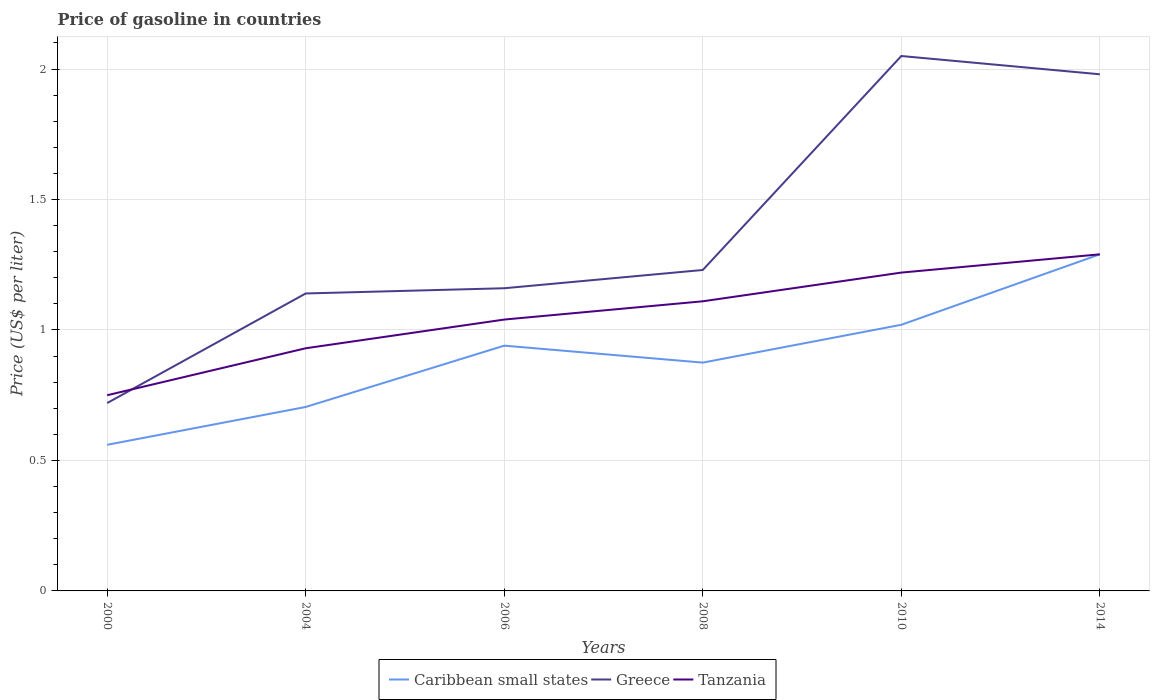How many different coloured lines are there?
Your answer should be very brief. 3. Does the line corresponding to Greece intersect with the line corresponding to Caribbean small states?
Your answer should be compact. No. Is the number of lines equal to the number of legend labels?
Your answer should be very brief. Yes. Across all years, what is the maximum price of gasoline in Greece?
Offer a very short reply. 0.72. In which year was the price of gasoline in Greece maximum?
Your answer should be compact. 2000. What is the total price of gasoline in Tanzania in the graph?
Provide a succinct answer. -0.36. What is the difference between the highest and the second highest price of gasoline in Caribbean small states?
Offer a terse response. 0.73. What is the difference between the highest and the lowest price of gasoline in Caribbean small states?
Keep it short and to the point. 3. Is the price of gasoline in Greece strictly greater than the price of gasoline in Caribbean small states over the years?
Provide a succinct answer. No. How many lines are there?
Provide a short and direct response. 3. What is the difference between two consecutive major ticks on the Y-axis?
Your answer should be compact. 0.5. Does the graph contain any zero values?
Give a very brief answer. No. Where does the legend appear in the graph?
Your answer should be compact. Bottom center. What is the title of the graph?
Make the answer very short. Price of gasoline in countries. Does "Haiti" appear as one of the legend labels in the graph?
Offer a very short reply. No. What is the label or title of the Y-axis?
Offer a very short reply. Price (US$ per liter). What is the Price (US$ per liter) in Caribbean small states in 2000?
Offer a very short reply. 0.56. What is the Price (US$ per liter) in Greece in 2000?
Make the answer very short. 0.72. What is the Price (US$ per liter) in Tanzania in 2000?
Provide a succinct answer. 0.75. What is the Price (US$ per liter) of Caribbean small states in 2004?
Ensure brevity in your answer.  0.7. What is the Price (US$ per liter) in Greece in 2004?
Offer a very short reply. 1.14. What is the Price (US$ per liter) in Tanzania in 2004?
Offer a very short reply. 0.93. What is the Price (US$ per liter) in Greece in 2006?
Offer a terse response. 1.16. What is the Price (US$ per liter) of Tanzania in 2006?
Offer a very short reply. 1.04. What is the Price (US$ per liter) in Greece in 2008?
Keep it short and to the point. 1.23. What is the Price (US$ per liter) of Tanzania in 2008?
Provide a succinct answer. 1.11. What is the Price (US$ per liter) in Greece in 2010?
Provide a short and direct response. 2.05. What is the Price (US$ per liter) in Tanzania in 2010?
Your response must be concise. 1.22. What is the Price (US$ per liter) of Caribbean small states in 2014?
Make the answer very short. 1.29. What is the Price (US$ per liter) of Greece in 2014?
Your answer should be compact. 1.98. What is the Price (US$ per liter) in Tanzania in 2014?
Ensure brevity in your answer.  1.29. Across all years, what is the maximum Price (US$ per liter) of Caribbean small states?
Your answer should be compact. 1.29. Across all years, what is the maximum Price (US$ per liter) of Greece?
Ensure brevity in your answer.  2.05. Across all years, what is the maximum Price (US$ per liter) in Tanzania?
Offer a terse response. 1.29. Across all years, what is the minimum Price (US$ per liter) in Caribbean small states?
Offer a terse response. 0.56. Across all years, what is the minimum Price (US$ per liter) in Greece?
Make the answer very short. 0.72. Across all years, what is the minimum Price (US$ per liter) in Tanzania?
Give a very brief answer. 0.75. What is the total Price (US$ per liter) in Caribbean small states in the graph?
Offer a terse response. 5.39. What is the total Price (US$ per liter) in Greece in the graph?
Your answer should be compact. 8.28. What is the total Price (US$ per liter) of Tanzania in the graph?
Provide a short and direct response. 6.34. What is the difference between the Price (US$ per liter) of Caribbean small states in 2000 and that in 2004?
Ensure brevity in your answer.  -0.14. What is the difference between the Price (US$ per liter) in Greece in 2000 and that in 2004?
Offer a very short reply. -0.42. What is the difference between the Price (US$ per liter) in Tanzania in 2000 and that in 2004?
Make the answer very short. -0.18. What is the difference between the Price (US$ per liter) in Caribbean small states in 2000 and that in 2006?
Offer a very short reply. -0.38. What is the difference between the Price (US$ per liter) in Greece in 2000 and that in 2006?
Provide a short and direct response. -0.44. What is the difference between the Price (US$ per liter) in Tanzania in 2000 and that in 2006?
Make the answer very short. -0.29. What is the difference between the Price (US$ per liter) of Caribbean small states in 2000 and that in 2008?
Give a very brief answer. -0.32. What is the difference between the Price (US$ per liter) of Greece in 2000 and that in 2008?
Your answer should be compact. -0.51. What is the difference between the Price (US$ per liter) in Tanzania in 2000 and that in 2008?
Give a very brief answer. -0.36. What is the difference between the Price (US$ per liter) in Caribbean small states in 2000 and that in 2010?
Provide a succinct answer. -0.46. What is the difference between the Price (US$ per liter) of Greece in 2000 and that in 2010?
Your answer should be compact. -1.33. What is the difference between the Price (US$ per liter) of Tanzania in 2000 and that in 2010?
Your answer should be very brief. -0.47. What is the difference between the Price (US$ per liter) in Caribbean small states in 2000 and that in 2014?
Provide a short and direct response. -0.73. What is the difference between the Price (US$ per liter) in Greece in 2000 and that in 2014?
Your answer should be very brief. -1.26. What is the difference between the Price (US$ per liter) of Tanzania in 2000 and that in 2014?
Offer a terse response. -0.54. What is the difference between the Price (US$ per liter) in Caribbean small states in 2004 and that in 2006?
Give a very brief answer. -0.23. What is the difference between the Price (US$ per liter) in Greece in 2004 and that in 2006?
Offer a very short reply. -0.02. What is the difference between the Price (US$ per liter) in Tanzania in 2004 and that in 2006?
Keep it short and to the point. -0.11. What is the difference between the Price (US$ per liter) in Caribbean small states in 2004 and that in 2008?
Provide a succinct answer. -0.17. What is the difference between the Price (US$ per liter) of Greece in 2004 and that in 2008?
Provide a short and direct response. -0.09. What is the difference between the Price (US$ per liter) of Tanzania in 2004 and that in 2008?
Your answer should be compact. -0.18. What is the difference between the Price (US$ per liter) in Caribbean small states in 2004 and that in 2010?
Make the answer very short. -0.32. What is the difference between the Price (US$ per liter) of Greece in 2004 and that in 2010?
Your answer should be very brief. -0.91. What is the difference between the Price (US$ per liter) in Tanzania in 2004 and that in 2010?
Provide a short and direct response. -0.29. What is the difference between the Price (US$ per liter) in Caribbean small states in 2004 and that in 2014?
Your response must be concise. -0.58. What is the difference between the Price (US$ per liter) in Greece in 2004 and that in 2014?
Give a very brief answer. -0.84. What is the difference between the Price (US$ per liter) of Tanzania in 2004 and that in 2014?
Provide a succinct answer. -0.36. What is the difference between the Price (US$ per liter) in Caribbean small states in 2006 and that in 2008?
Your answer should be very brief. 0.07. What is the difference between the Price (US$ per liter) in Greece in 2006 and that in 2008?
Make the answer very short. -0.07. What is the difference between the Price (US$ per liter) in Tanzania in 2006 and that in 2008?
Provide a short and direct response. -0.07. What is the difference between the Price (US$ per liter) in Caribbean small states in 2006 and that in 2010?
Offer a terse response. -0.08. What is the difference between the Price (US$ per liter) of Greece in 2006 and that in 2010?
Offer a very short reply. -0.89. What is the difference between the Price (US$ per liter) in Tanzania in 2006 and that in 2010?
Provide a short and direct response. -0.18. What is the difference between the Price (US$ per liter) of Caribbean small states in 2006 and that in 2014?
Provide a succinct answer. -0.35. What is the difference between the Price (US$ per liter) of Greece in 2006 and that in 2014?
Provide a short and direct response. -0.82. What is the difference between the Price (US$ per liter) in Tanzania in 2006 and that in 2014?
Provide a succinct answer. -0.25. What is the difference between the Price (US$ per liter) of Caribbean small states in 2008 and that in 2010?
Give a very brief answer. -0.14. What is the difference between the Price (US$ per liter) of Greece in 2008 and that in 2010?
Keep it short and to the point. -0.82. What is the difference between the Price (US$ per liter) in Tanzania in 2008 and that in 2010?
Make the answer very short. -0.11. What is the difference between the Price (US$ per liter) in Caribbean small states in 2008 and that in 2014?
Your answer should be compact. -0.41. What is the difference between the Price (US$ per liter) in Greece in 2008 and that in 2014?
Provide a succinct answer. -0.75. What is the difference between the Price (US$ per liter) in Tanzania in 2008 and that in 2014?
Ensure brevity in your answer.  -0.18. What is the difference between the Price (US$ per liter) in Caribbean small states in 2010 and that in 2014?
Your answer should be compact. -0.27. What is the difference between the Price (US$ per liter) in Greece in 2010 and that in 2014?
Your answer should be very brief. 0.07. What is the difference between the Price (US$ per liter) in Tanzania in 2010 and that in 2014?
Your answer should be very brief. -0.07. What is the difference between the Price (US$ per liter) in Caribbean small states in 2000 and the Price (US$ per liter) in Greece in 2004?
Provide a succinct answer. -0.58. What is the difference between the Price (US$ per liter) in Caribbean small states in 2000 and the Price (US$ per liter) in Tanzania in 2004?
Provide a succinct answer. -0.37. What is the difference between the Price (US$ per liter) of Greece in 2000 and the Price (US$ per liter) of Tanzania in 2004?
Provide a short and direct response. -0.21. What is the difference between the Price (US$ per liter) in Caribbean small states in 2000 and the Price (US$ per liter) in Greece in 2006?
Make the answer very short. -0.6. What is the difference between the Price (US$ per liter) in Caribbean small states in 2000 and the Price (US$ per liter) in Tanzania in 2006?
Make the answer very short. -0.48. What is the difference between the Price (US$ per liter) of Greece in 2000 and the Price (US$ per liter) of Tanzania in 2006?
Your response must be concise. -0.32. What is the difference between the Price (US$ per liter) in Caribbean small states in 2000 and the Price (US$ per liter) in Greece in 2008?
Your answer should be very brief. -0.67. What is the difference between the Price (US$ per liter) of Caribbean small states in 2000 and the Price (US$ per liter) of Tanzania in 2008?
Give a very brief answer. -0.55. What is the difference between the Price (US$ per liter) of Greece in 2000 and the Price (US$ per liter) of Tanzania in 2008?
Ensure brevity in your answer.  -0.39. What is the difference between the Price (US$ per liter) in Caribbean small states in 2000 and the Price (US$ per liter) in Greece in 2010?
Give a very brief answer. -1.49. What is the difference between the Price (US$ per liter) of Caribbean small states in 2000 and the Price (US$ per liter) of Tanzania in 2010?
Offer a very short reply. -0.66. What is the difference between the Price (US$ per liter) in Greece in 2000 and the Price (US$ per liter) in Tanzania in 2010?
Give a very brief answer. -0.5. What is the difference between the Price (US$ per liter) in Caribbean small states in 2000 and the Price (US$ per liter) in Greece in 2014?
Offer a very short reply. -1.42. What is the difference between the Price (US$ per liter) of Caribbean small states in 2000 and the Price (US$ per liter) of Tanzania in 2014?
Offer a terse response. -0.73. What is the difference between the Price (US$ per liter) of Greece in 2000 and the Price (US$ per liter) of Tanzania in 2014?
Your answer should be compact. -0.57. What is the difference between the Price (US$ per liter) in Caribbean small states in 2004 and the Price (US$ per liter) in Greece in 2006?
Offer a very short reply. -0.46. What is the difference between the Price (US$ per liter) of Caribbean small states in 2004 and the Price (US$ per liter) of Tanzania in 2006?
Ensure brevity in your answer.  -0.34. What is the difference between the Price (US$ per liter) of Caribbean small states in 2004 and the Price (US$ per liter) of Greece in 2008?
Offer a terse response. -0.53. What is the difference between the Price (US$ per liter) in Caribbean small states in 2004 and the Price (US$ per liter) in Tanzania in 2008?
Offer a very short reply. -0.41. What is the difference between the Price (US$ per liter) of Caribbean small states in 2004 and the Price (US$ per liter) of Greece in 2010?
Your response must be concise. -1.34. What is the difference between the Price (US$ per liter) of Caribbean small states in 2004 and the Price (US$ per liter) of Tanzania in 2010?
Your answer should be very brief. -0.52. What is the difference between the Price (US$ per liter) in Greece in 2004 and the Price (US$ per liter) in Tanzania in 2010?
Your response must be concise. -0.08. What is the difference between the Price (US$ per liter) in Caribbean small states in 2004 and the Price (US$ per liter) in Greece in 2014?
Give a very brief answer. -1.27. What is the difference between the Price (US$ per liter) of Caribbean small states in 2004 and the Price (US$ per liter) of Tanzania in 2014?
Keep it short and to the point. -0.58. What is the difference between the Price (US$ per liter) in Caribbean small states in 2006 and the Price (US$ per liter) in Greece in 2008?
Ensure brevity in your answer.  -0.29. What is the difference between the Price (US$ per liter) in Caribbean small states in 2006 and the Price (US$ per liter) in Tanzania in 2008?
Ensure brevity in your answer.  -0.17. What is the difference between the Price (US$ per liter) of Caribbean small states in 2006 and the Price (US$ per liter) of Greece in 2010?
Offer a very short reply. -1.11. What is the difference between the Price (US$ per liter) in Caribbean small states in 2006 and the Price (US$ per liter) in Tanzania in 2010?
Your answer should be compact. -0.28. What is the difference between the Price (US$ per liter) in Greece in 2006 and the Price (US$ per liter) in Tanzania in 2010?
Ensure brevity in your answer.  -0.06. What is the difference between the Price (US$ per liter) of Caribbean small states in 2006 and the Price (US$ per liter) of Greece in 2014?
Give a very brief answer. -1.04. What is the difference between the Price (US$ per liter) in Caribbean small states in 2006 and the Price (US$ per liter) in Tanzania in 2014?
Keep it short and to the point. -0.35. What is the difference between the Price (US$ per liter) in Greece in 2006 and the Price (US$ per liter) in Tanzania in 2014?
Give a very brief answer. -0.13. What is the difference between the Price (US$ per liter) in Caribbean small states in 2008 and the Price (US$ per liter) in Greece in 2010?
Offer a terse response. -1.18. What is the difference between the Price (US$ per liter) in Caribbean small states in 2008 and the Price (US$ per liter) in Tanzania in 2010?
Ensure brevity in your answer.  -0.34. What is the difference between the Price (US$ per liter) in Caribbean small states in 2008 and the Price (US$ per liter) in Greece in 2014?
Your response must be concise. -1.1. What is the difference between the Price (US$ per liter) of Caribbean small states in 2008 and the Price (US$ per liter) of Tanzania in 2014?
Offer a terse response. -0.41. What is the difference between the Price (US$ per liter) in Greece in 2008 and the Price (US$ per liter) in Tanzania in 2014?
Provide a short and direct response. -0.06. What is the difference between the Price (US$ per liter) of Caribbean small states in 2010 and the Price (US$ per liter) of Greece in 2014?
Provide a succinct answer. -0.96. What is the difference between the Price (US$ per liter) in Caribbean small states in 2010 and the Price (US$ per liter) in Tanzania in 2014?
Your answer should be very brief. -0.27. What is the difference between the Price (US$ per liter) of Greece in 2010 and the Price (US$ per liter) of Tanzania in 2014?
Provide a succinct answer. 0.76. What is the average Price (US$ per liter) in Caribbean small states per year?
Ensure brevity in your answer.  0.9. What is the average Price (US$ per liter) of Greece per year?
Provide a short and direct response. 1.38. What is the average Price (US$ per liter) of Tanzania per year?
Offer a very short reply. 1.06. In the year 2000, what is the difference between the Price (US$ per liter) in Caribbean small states and Price (US$ per liter) in Greece?
Provide a short and direct response. -0.16. In the year 2000, what is the difference between the Price (US$ per liter) of Caribbean small states and Price (US$ per liter) of Tanzania?
Your answer should be very brief. -0.19. In the year 2000, what is the difference between the Price (US$ per liter) in Greece and Price (US$ per liter) in Tanzania?
Offer a very short reply. -0.03. In the year 2004, what is the difference between the Price (US$ per liter) in Caribbean small states and Price (US$ per liter) in Greece?
Offer a very short reply. -0.43. In the year 2004, what is the difference between the Price (US$ per liter) of Caribbean small states and Price (US$ per liter) of Tanzania?
Offer a terse response. -0.23. In the year 2004, what is the difference between the Price (US$ per liter) of Greece and Price (US$ per liter) of Tanzania?
Provide a succinct answer. 0.21. In the year 2006, what is the difference between the Price (US$ per liter) of Caribbean small states and Price (US$ per liter) of Greece?
Make the answer very short. -0.22. In the year 2006, what is the difference between the Price (US$ per liter) in Caribbean small states and Price (US$ per liter) in Tanzania?
Your answer should be very brief. -0.1. In the year 2006, what is the difference between the Price (US$ per liter) in Greece and Price (US$ per liter) in Tanzania?
Provide a short and direct response. 0.12. In the year 2008, what is the difference between the Price (US$ per liter) in Caribbean small states and Price (US$ per liter) in Greece?
Your response must be concise. -0.35. In the year 2008, what is the difference between the Price (US$ per liter) in Caribbean small states and Price (US$ per liter) in Tanzania?
Make the answer very short. -0.23. In the year 2008, what is the difference between the Price (US$ per liter) of Greece and Price (US$ per liter) of Tanzania?
Keep it short and to the point. 0.12. In the year 2010, what is the difference between the Price (US$ per liter) in Caribbean small states and Price (US$ per liter) in Greece?
Offer a very short reply. -1.03. In the year 2010, what is the difference between the Price (US$ per liter) in Greece and Price (US$ per liter) in Tanzania?
Make the answer very short. 0.83. In the year 2014, what is the difference between the Price (US$ per liter) in Caribbean small states and Price (US$ per liter) in Greece?
Make the answer very short. -0.69. In the year 2014, what is the difference between the Price (US$ per liter) in Caribbean small states and Price (US$ per liter) in Tanzania?
Your response must be concise. 0. In the year 2014, what is the difference between the Price (US$ per liter) of Greece and Price (US$ per liter) of Tanzania?
Provide a succinct answer. 0.69. What is the ratio of the Price (US$ per liter) of Caribbean small states in 2000 to that in 2004?
Offer a terse response. 0.79. What is the ratio of the Price (US$ per liter) in Greece in 2000 to that in 2004?
Provide a succinct answer. 0.63. What is the ratio of the Price (US$ per liter) in Tanzania in 2000 to that in 2004?
Offer a very short reply. 0.81. What is the ratio of the Price (US$ per liter) in Caribbean small states in 2000 to that in 2006?
Keep it short and to the point. 0.6. What is the ratio of the Price (US$ per liter) in Greece in 2000 to that in 2006?
Offer a very short reply. 0.62. What is the ratio of the Price (US$ per liter) in Tanzania in 2000 to that in 2006?
Give a very brief answer. 0.72. What is the ratio of the Price (US$ per liter) of Caribbean small states in 2000 to that in 2008?
Offer a terse response. 0.64. What is the ratio of the Price (US$ per liter) in Greece in 2000 to that in 2008?
Offer a terse response. 0.59. What is the ratio of the Price (US$ per liter) of Tanzania in 2000 to that in 2008?
Keep it short and to the point. 0.68. What is the ratio of the Price (US$ per liter) in Caribbean small states in 2000 to that in 2010?
Make the answer very short. 0.55. What is the ratio of the Price (US$ per liter) of Greece in 2000 to that in 2010?
Give a very brief answer. 0.35. What is the ratio of the Price (US$ per liter) in Tanzania in 2000 to that in 2010?
Make the answer very short. 0.61. What is the ratio of the Price (US$ per liter) in Caribbean small states in 2000 to that in 2014?
Keep it short and to the point. 0.43. What is the ratio of the Price (US$ per liter) of Greece in 2000 to that in 2014?
Provide a short and direct response. 0.36. What is the ratio of the Price (US$ per liter) in Tanzania in 2000 to that in 2014?
Your response must be concise. 0.58. What is the ratio of the Price (US$ per liter) in Caribbean small states in 2004 to that in 2006?
Ensure brevity in your answer.  0.75. What is the ratio of the Price (US$ per liter) of Greece in 2004 to that in 2006?
Provide a succinct answer. 0.98. What is the ratio of the Price (US$ per liter) of Tanzania in 2004 to that in 2006?
Give a very brief answer. 0.89. What is the ratio of the Price (US$ per liter) of Caribbean small states in 2004 to that in 2008?
Your answer should be compact. 0.81. What is the ratio of the Price (US$ per liter) of Greece in 2004 to that in 2008?
Your answer should be very brief. 0.93. What is the ratio of the Price (US$ per liter) in Tanzania in 2004 to that in 2008?
Provide a short and direct response. 0.84. What is the ratio of the Price (US$ per liter) in Caribbean small states in 2004 to that in 2010?
Provide a short and direct response. 0.69. What is the ratio of the Price (US$ per liter) in Greece in 2004 to that in 2010?
Your response must be concise. 0.56. What is the ratio of the Price (US$ per liter) in Tanzania in 2004 to that in 2010?
Ensure brevity in your answer.  0.76. What is the ratio of the Price (US$ per liter) in Caribbean small states in 2004 to that in 2014?
Offer a very short reply. 0.55. What is the ratio of the Price (US$ per liter) of Greece in 2004 to that in 2014?
Ensure brevity in your answer.  0.58. What is the ratio of the Price (US$ per liter) of Tanzania in 2004 to that in 2014?
Provide a succinct answer. 0.72. What is the ratio of the Price (US$ per liter) in Caribbean small states in 2006 to that in 2008?
Provide a succinct answer. 1.07. What is the ratio of the Price (US$ per liter) in Greece in 2006 to that in 2008?
Give a very brief answer. 0.94. What is the ratio of the Price (US$ per liter) in Tanzania in 2006 to that in 2008?
Your response must be concise. 0.94. What is the ratio of the Price (US$ per liter) of Caribbean small states in 2006 to that in 2010?
Your response must be concise. 0.92. What is the ratio of the Price (US$ per liter) of Greece in 2006 to that in 2010?
Your answer should be compact. 0.57. What is the ratio of the Price (US$ per liter) of Tanzania in 2006 to that in 2010?
Ensure brevity in your answer.  0.85. What is the ratio of the Price (US$ per liter) in Caribbean small states in 2006 to that in 2014?
Your response must be concise. 0.73. What is the ratio of the Price (US$ per liter) in Greece in 2006 to that in 2014?
Your answer should be very brief. 0.59. What is the ratio of the Price (US$ per liter) in Tanzania in 2006 to that in 2014?
Offer a very short reply. 0.81. What is the ratio of the Price (US$ per liter) of Caribbean small states in 2008 to that in 2010?
Your response must be concise. 0.86. What is the ratio of the Price (US$ per liter) of Tanzania in 2008 to that in 2010?
Your answer should be very brief. 0.91. What is the ratio of the Price (US$ per liter) of Caribbean small states in 2008 to that in 2014?
Offer a very short reply. 0.68. What is the ratio of the Price (US$ per liter) of Greece in 2008 to that in 2014?
Your answer should be very brief. 0.62. What is the ratio of the Price (US$ per liter) of Tanzania in 2008 to that in 2014?
Provide a short and direct response. 0.86. What is the ratio of the Price (US$ per liter) in Caribbean small states in 2010 to that in 2014?
Provide a short and direct response. 0.79. What is the ratio of the Price (US$ per liter) in Greece in 2010 to that in 2014?
Provide a succinct answer. 1.04. What is the ratio of the Price (US$ per liter) of Tanzania in 2010 to that in 2014?
Give a very brief answer. 0.95. What is the difference between the highest and the second highest Price (US$ per liter) in Caribbean small states?
Your response must be concise. 0.27. What is the difference between the highest and the second highest Price (US$ per liter) in Greece?
Offer a very short reply. 0.07. What is the difference between the highest and the second highest Price (US$ per liter) of Tanzania?
Make the answer very short. 0.07. What is the difference between the highest and the lowest Price (US$ per liter) of Caribbean small states?
Ensure brevity in your answer.  0.73. What is the difference between the highest and the lowest Price (US$ per liter) of Greece?
Your response must be concise. 1.33. What is the difference between the highest and the lowest Price (US$ per liter) in Tanzania?
Provide a short and direct response. 0.54. 